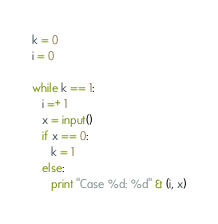<code> <loc_0><loc_0><loc_500><loc_500><_Python_>k = 0
i = 0
  
while k == 1:
   i =+ 1
   x = input()
   if x == 0:
      k = 1
   else:
      print "Case %d: %d" & (i, x)</code> 